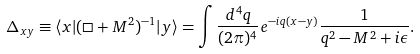<formula> <loc_0><loc_0><loc_500><loc_500>\Delta _ { x y } \equiv \langle x | ( \Box + M ^ { 2 } ) ^ { - 1 } | y \rangle = \int \frac { d ^ { 4 } q } { ( 2 \pi ) ^ { 4 } } e ^ { - i q ( x - y ) } \frac { 1 } { q ^ { 2 } - M ^ { 2 } + i \epsilon } .</formula> 